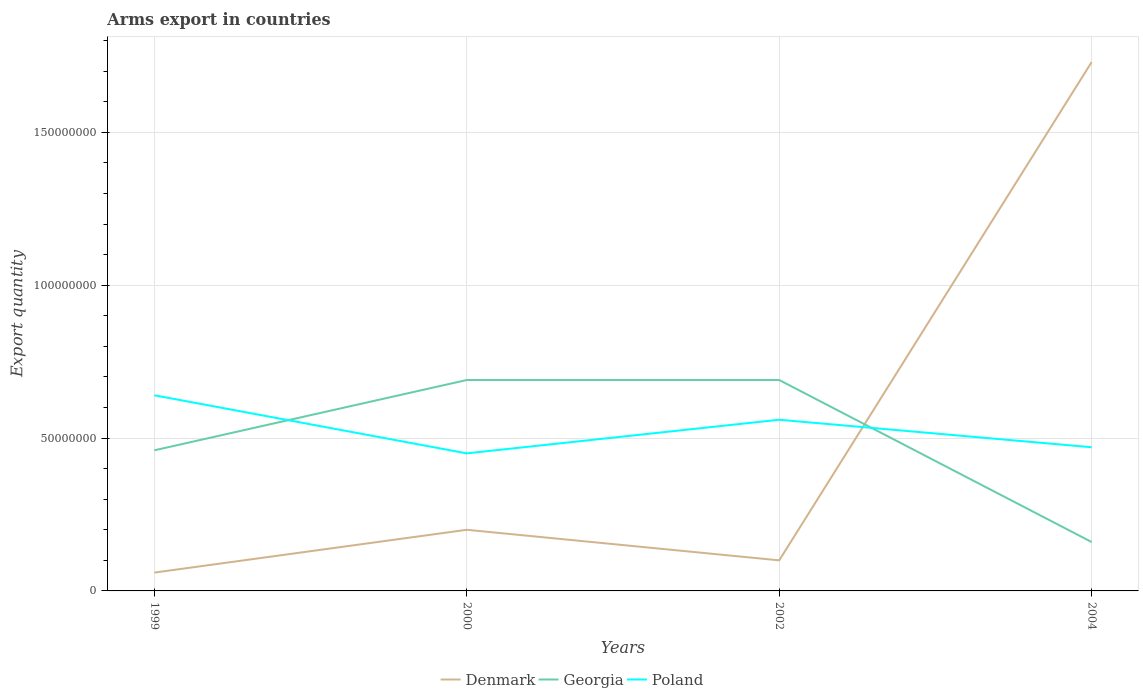Does the line corresponding to Georgia intersect with the line corresponding to Denmark?
Provide a succinct answer. Yes. Is the number of lines equal to the number of legend labels?
Keep it short and to the point. Yes. In which year was the total arms export in Georgia maximum?
Offer a very short reply. 2004. What is the total total arms export in Poland in the graph?
Keep it short and to the point. 1.90e+07. What is the difference between the highest and the second highest total arms export in Poland?
Make the answer very short. 1.90e+07. How many lines are there?
Make the answer very short. 3. What is the difference between two consecutive major ticks on the Y-axis?
Offer a terse response. 5.00e+07. Does the graph contain any zero values?
Give a very brief answer. No. How are the legend labels stacked?
Make the answer very short. Horizontal. What is the title of the graph?
Ensure brevity in your answer.  Arms export in countries. What is the label or title of the Y-axis?
Your answer should be very brief. Export quantity. What is the Export quantity in Georgia in 1999?
Offer a very short reply. 4.60e+07. What is the Export quantity of Poland in 1999?
Ensure brevity in your answer.  6.40e+07. What is the Export quantity in Denmark in 2000?
Offer a terse response. 2.00e+07. What is the Export quantity in Georgia in 2000?
Make the answer very short. 6.90e+07. What is the Export quantity in Poland in 2000?
Provide a succinct answer. 4.50e+07. What is the Export quantity in Georgia in 2002?
Offer a terse response. 6.90e+07. What is the Export quantity of Poland in 2002?
Provide a succinct answer. 5.60e+07. What is the Export quantity in Denmark in 2004?
Your answer should be compact. 1.73e+08. What is the Export quantity in Georgia in 2004?
Give a very brief answer. 1.60e+07. What is the Export quantity of Poland in 2004?
Offer a very short reply. 4.70e+07. Across all years, what is the maximum Export quantity of Denmark?
Provide a succinct answer. 1.73e+08. Across all years, what is the maximum Export quantity of Georgia?
Offer a very short reply. 6.90e+07. Across all years, what is the maximum Export quantity of Poland?
Make the answer very short. 6.40e+07. Across all years, what is the minimum Export quantity in Denmark?
Ensure brevity in your answer.  6.00e+06. Across all years, what is the minimum Export quantity of Georgia?
Offer a very short reply. 1.60e+07. Across all years, what is the minimum Export quantity of Poland?
Provide a succinct answer. 4.50e+07. What is the total Export quantity of Denmark in the graph?
Make the answer very short. 2.09e+08. What is the total Export quantity in Georgia in the graph?
Provide a succinct answer. 2.00e+08. What is the total Export quantity of Poland in the graph?
Ensure brevity in your answer.  2.12e+08. What is the difference between the Export quantity of Denmark in 1999 and that in 2000?
Keep it short and to the point. -1.40e+07. What is the difference between the Export quantity in Georgia in 1999 and that in 2000?
Provide a short and direct response. -2.30e+07. What is the difference between the Export quantity of Poland in 1999 and that in 2000?
Your answer should be compact. 1.90e+07. What is the difference between the Export quantity in Denmark in 1999 and that in 2002?
Give a very brief answer. -4.00e+06. What is the difference between the Export quantity in Georgia in 1999 and that in 2002?
Provide a succinct answer. -2.30e+07. What is the difference between the Export quantity in Denmark in 1999 and that in 2004?
Provide a short and direct response. -1.67e+08. What is the difference between the Export quantity of Georgia in 1999 and that in 2004?
Keep it short and to the point. 3.00e+07. What is the difference between the Export quantity of Poland in 1999 and that in 2004?
Provide a succinct answer. 1.70e+07. What is the difference between the Export quantity in Poland in 2000 and that in 2002?
Ensure brevity in your answer.  -1.10e+07. What is the difference between the Export quantity in Denmark in 2000 and that in 2004?
Your response must be concise. -1.53e+08. What is the difference between the Export quantity of Georgia in 2000 and that in 2004?
Offer a terse response. 5.30e+07. What is the difference between the Export quantity in Poland in 2000 and that in 2004?
Your response must be concise. -2.00e+06. What is the difference between the Export quantity in Denmark in 2002 and that in 2004?
Offer a very short reply. -1.63e+08. What is the difference between the Export quantity of Georgia in 2002 and that in 2004?
Provide a short and direct response. 5.30e+07. What is the difference between the Export quantity in Poland in 2002 and that in 2004?
Your answer should be compact. 9.00e+06. What is the difference between the Export quantity of Denmark in 1999 and the Export quantity of Georgia in 2000?
Offer a very short reply. -6.30e+07. What is the difference between the Export quantity in Denmark in 1999 and the Export quantity in Poland in 2000?
Your answer should be very brief. -3.90e+07. What is the difference between the Export quantity in Georgia in 1999 and the Export quantity in Poland in 2000?
Offer a terse response. 1.00e+06. What is the difference between the Export quantity in Denmark in 1999 and the Export quantity in Georgia in 2002?
Keep it short and to the point. -6.30e+07. What is the difference between the Export quantity in Denmark in 1999 and the Export quantity in Poland in 2002?
Give a very brief answer. -5.00e+07. What is the difference between the Export quantity in Georgia in 1999 and the Export quantity in Poland in 2002?
Offer a very short reply. -1.00e+07. What is the difference between the Export quantity of Denmark in 1999 and the Export quantity of Georgia in 2004?
Offer a terse response. -1.00e+07. What is the difference between the Export quantity in Denmark in 1999 and the Export quantity in Poland in 2004?
Your answer should be very brief. -4.10e+07. What is the difference between the Export quantity of Georgia in 1999 and the Export quantity of Poland in 2004?
Your answer should be very brief. -1.00e+06. What is the difference between the Export quantity of Denmark in 2000 and the Export quantity of Georgia in 2002?
Offer a terse response. -4.90e+07. What is the difference between the Export quantity of Denmark in 2000 and the Export quantity of Poland in 2002?
Offer a very short reply. -3.60e+07. What is the difference between the Export quantity of Georgia in 2000 and the Export quantity of Poland in 2002?
Keep it short and to the point. 1.30e+07. What is the difference between the Export quantity in Denmark in 2000 and the Export quantity in Poland in 2004?
Your answer should be very brief. -2.70e+07. What is the difference between the Export quantity in Georgia in 2000 and the Export quantity in Poland in 2004?
Your answer should be compact. 2.20e+07. What is the difference between the Export quantity in Denmark in 2002 and the Export quantity in Georgia in 2004?
Provide a succinct answer. -6.00e+06. What is the difference between the Export quantity of Denmark in 2002 and the Export quantity of Poland in 2004?
Keep it short and to the point. -3.70e+07. What is the difference between the Export quantity in Georgia in 2002 and the Export quantity in Poland in 2004?
Provide a short and direct response. 2.20e+07. What is the average Export quantity of Denmark per year?
Offer a terse response. 5.22e+07. What is the average Export quantity of Poland per year?
Offer a very short reply. 5.30e+07. In the year 1999, what is the difference between the Export quantity of Denmark and Export quantity of Georgia?
Your answer should be compact. -4.00e+07. In the year 1999, what is the difference between the Export quantity of Denmark and Export quantity of Poland?
Ensure brevity in your answer.  -5.80e+07. In the year 1999, what is the difference between the Export quantity of Georgia and Export quantity of Poland?
Your answer should be very brief. -1.80e+07. In the year 2000, what is the difference between the Export quantity of Denmark and Export quantity of Georgia?
Offer a very short reply. -4.90e+07. In the year 2000, what is the difference between the Export quantity in Denmark and Export quantity in Poland?
Provide a succinct answer. -2.50e+07. In the year 2000, what is the difference between the Export quantity in Georgia and Export quantity in Poland?
Make the answer very short. 2.40e+07. In the year 2002, what is the difference between the Export quantity of Denmark and Export quantity of Georgia?
Ensure brevity in your answer.  -5.90e+07. In the year 2002, what is the difference between the Export quantity of Denmark and Export quantity of Poland?
Provide a short and direct response. -4.60e+07. In the year 2002, what is the difference between the Export quantity of Georgia and Export quantity of Poland?
Your answer should be very brief. 1.30e+07. In the year 2004, what is the difference between the Export quantity in Denmark and Export quantity in Georgia?
Offer a very short reply. 1.57e+08. In the year 2004, what is the difference between the Export quantity of Denmark and Export quantity of Poland?
Your answer should be very brief. 1.26e+08. In the year 2004, what is the difference between the Export quantity in Georgia and Export quantity in Poland?
Your answer should be very brief. -3.10e+07. What is the ratio of the Export quantity of Denmark in 1999 to that in 2000?
Provide a short and direct response. 0.3. What is the ratio of the Export quantity in Georgia in 1999 to that in 2000?
Provide a short and direct response. 0.67. What is the ratio of the Export quantity in Poland in 1999 to that in 2000?
Your answer should be very brief. 1.42. What is the ratio of the Export quantity of Denmark in 1999 to that in 2002?
Your response must be concise. 0.6. What is the ratio of the Export quantity of Denmark in 1999 to that in 2004?
Your answer should be compact. 0.03. What is the ratio of the Export quantity of Georgia in 1999 to that in 2004?
Offer a very short reply. 2.88. What is the ratio of the Export quantity of Poland in 1999 to that in 2004?
Your response must be concise. 1.36. What is the ratio of the Export quantity in Georgia in 2000 to that in 2002?
Offer a very short reply. 1. What is the ratio of the Export quantity in Poland in 2000 to that in 2002?
Offer a very short reply. 0.8. What is the ratio of the Export quantity in Denmark in 2000 to that in 2004?
Offer a very short reply. 0.12. What is the ratio of the Export quantity in Georgia in 2000 to that in 2004?
Give a very brief answer. 4.31. What is the ratio of the Export quantity of Poland in 2000 to that in 2004?
Ensure brevity in your answer.  0.96. What is the ratio of the Export quantity of Denmark in 2002 to that in 2004?
Offer a terse response. 0.06. What is the ratio of the Export quantity in Georgia in 2002 to that in 2004?
Your answer should be very brief. 4.31. What is the ratio of the Export quantity of Poland in 2002 to that in 2004?
Keep it short and to the point. 1.19. What is the difference between the highest and the second highest Export quantity of Denmark?
Provide a short and direct response. 1.53e+08. What is the difference between the highest and the lowest Export quantity of Denmark?
Provide a succinct answer. 1.67e+08. What is the difference between the highest and the lowest Export quantity of Georgia?
Make the answer very short. 5.30e+07. What is the difference between the highest and the lowest Export quantity of Poland?
Make the answer very short. 1.90e+07. 